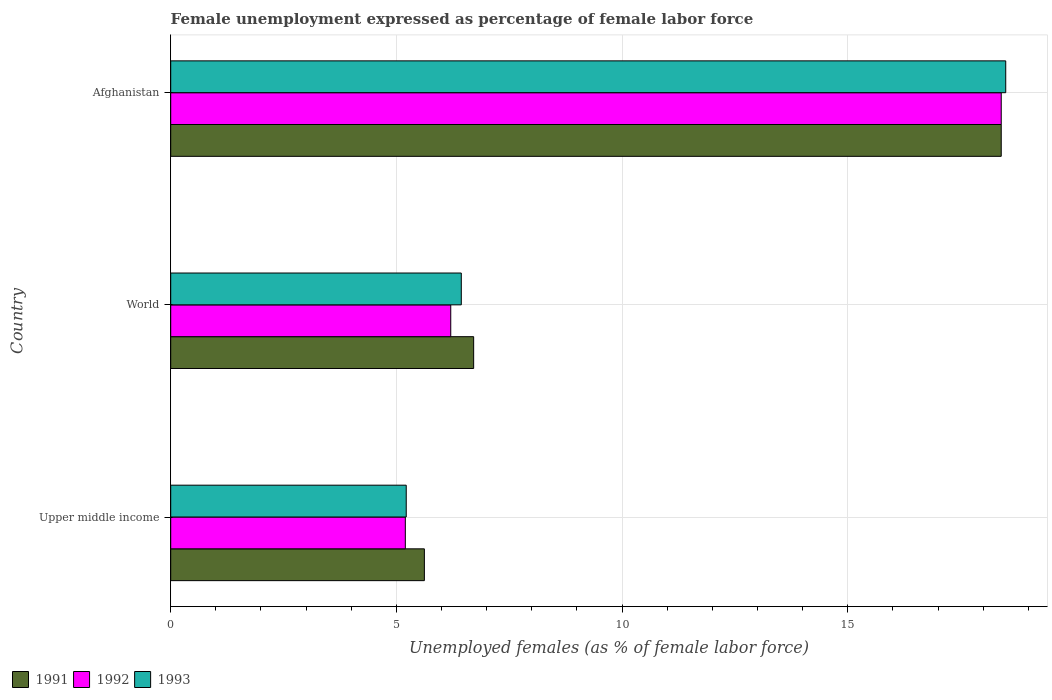How many different coloured bars are there?
Keep it short and to the point. 3. How many groups of bars are there?
Keep it short and to the point. 3. Are the number of bars on each tick of the Y-axis equal?
Provide a short and direct response. Yes. How many bars are there on the 3rd tick from the top?
Offer a terse response. 3. How many bars are there on the 2nd tick from the bottom?
Offer a terse response. 3. What is the label of the 1st group of bars from the top?
Offer a very short reply. Afghanistan. What is the unemployment in females in in 1991 in Afghanistan?
Give a very brief answer. 18.4. Across all countries, what is the maximum unemployment in females in in 1991?
Provide a succinct answer. 18.4. Across all countries, what is the minimum unemployment in females in in 1992?
Make the answer very short. 5.2. In which country was the unemployment in females in in 1993 maximum?
Make the answer very short. Afghanistan. In which country was the unemployment in females in in 1991 minimum?
Ensure brevity in your answer.  Upper middle income. What is the total unemployment in females in in 1991 in the graph?
Your response must be concise. 30.73. What is the difference between the unemployment in females in in 1991 in Upper middle income and that in World?
Provide a succinct answer. -1.09. What is the difference between the unemployment in females in in 1992 in Upper middle income and the unemployment in females in in 1991 in World?
Keep it short and to the point. -1.51. What is the average unemployment in females in in 1993 per country?
Ensure brevity in your answer.  10.05. What is the difference between the unemployment in females in in 1991 and unemployment in females in in 1992 in Upper middle income?
Your answer should be compact. 0.42. What is the ratio of the unemployment in females in in 1992 in Afghanistan to that in Upper middle income?
Give a very brief answer. 3.54. What is the difference between the highest and the second highest unemployment in females in in 1992?
Your response must be concise. 12.2. What is the difference between the highest and the lowest unemployment in females in in 1992?
Give a very brief answer. 13.2. In how many countries, is the unemployment in females in in 1993 greater than the average unemployment in females in in 1993 taken over all countries?
Keep it short and to the point. 1. Is it the case that in every country, the sum of the unemployment in females in in 1991 and unemployment in females in in 1992 is greater than the unemployment in females in in 1993?
Keep it short and to the point. Yes. Are all the bars in the graph horizontal?
Give a very brief answer. Yes. What is the difference between two consecutive major ticks on the X-axis?
Your response must be concise. 5. Where does the legend appear in the graph?
Provide a succinct answer. Bottom left. What is the title of the graph?
Provide a short and direct response. Female unemployment expressed as percentage of female labor force. What is the label or title of the X-axis?
Offer a very short reply. Unemployed females (as % of female labor force). What is the label or title of the Y-axis?
Offer a very short reply. Country. What is the Unemployed females (as % of female labor force) in 1991 in Upper middle income?
Ensure brevity in your answer.  5.62. What is the Unemployed females (as % of female labor force) of 1992 in Upper middle income?
Offer a terse response. 5.2. What is the Unemployed females (as % of female labor force) in 1993 in Upper middle income?
Offer a very short reply. 5.22. What is the Unemployed females (as % of female labor force) of 1991 in World?
Offer a terse response. 6.71. What is the Unemployed females (as % of female labor force) in 1992 in World?
Offer a very short reply. 6.2. What is the Unemployed females (as % of female labor force) in 1993 in World?
Make the answer very short. 6.44. What is the Unemployed females (as % of female labor force) of 1991 in Afghanistan?
Provide a short and direct response. 18.4. What is the Unemployed females (as % of female labor force) of 1992 in Afghanistan?
Offer a very short reply. 18.4. Across all countries, what is the maximum Unemployed females (as % of female labor force) of 1991?
Ensure brevity in your answer.  18.4. Across all countries, what is the maximum Unemployed females (as % of female labor force) of 1992?
Make the answer very short. 18.4. Across all countries, what is the maximum Unemployed females (as % of female labor force) in 1993?
Offer a terse response. 18.5. Across all countries, what is the minimum Unemployed females (as % of female labor force) of 1991?
Offer a very short reply. 5.62. Across all countries, what is the minimum Unemployed females (as % of female labor force) of 1992?
Your answer should be compact. 5.2. Across all countries, what is the minimum Unemployed females (as % of female labor force) in 1993?
Provide a short and direct response. 5.22. What is the total Unemployed females (as % of female labor force) of 1991 in the graph?
Offer a terse response. 30.73. What is the total Unemployed females (as % of female labor force) in 1992 in the graph?
Keep it short and to the point. 29.8. What is the total Unemployed females (as % of female labor force) in 1993 in the graph?
Offer a terse response. 30.16. What is the difference between the Unemployed females (as % of female labor force) of 1991 in Upper middle income and that in World?
Your answer should be compact. -1.09. What is the difference between the Unemployed females (as % of female labor force) in 1992 in Upper middle income and that in World?
Your answer should be compact. -1.01. What is the difference between the Unemployed females (as % of female labor force) in 1993 in Upper middle income and that in World?
Make the answer very short. -1.22. What is the difference between the Unemployed females (as % of female labor force) in 1991 in Upper middle income and that in Afghanistan?
Your answer should be compact. -12.78. What is the difference between the Unemployed females (as % of female labor force) in 1992 in Upper middle income and that in Afghanistan?
Offer a terse response. -13.2. What is the difference between the Unemployed females (as % of female labor force) in 1993 in Upper middle income and that in Afghanistan?
Keep it short and to the point. -13.28. What is the difference between the Unemployed females (as % of female labor force) of 1991 in World and that in Afghanistan?
Provide a short and direct response. -11.69. What is the difference between the Unemployed females (as % of female labor force) of 1992 in World and that in Afghanistan?
Provide a short and direct response. -12.2. What is the difference between the Unemployed females (as % of female labor force) of 1993 in World and that in Afghanistan?
Provide a short and direct response. -12.06. What is the difference between the Unemployed females (as % of female labor force) in 1991 in Upper middle income and the Unemployed females (as % of female labor force) in 1992 in World?
Your answer should be compact. -0.58. What is the difference between the Unemployed females (as % of female labor force) of 1991 in Upper middle income and the Unemployed females (as % of female labor force) of 1993 in World?
Offer a terse response. -0.82. What is the difference between the Unemployed females (as % of female labor force) in 1992 in Upper middle income and the Unemployed females (as % of female labor force) in 1993 in World?
Offer a very short reply. -1.24. What is the difference between the Unemployed females (as % of female labor force) in 1991 in Upper middle income and the Unemployed females (as % of female labor force) in 1992 in Afghanistan?
Make the answer very short. -12.78. What is the difference between the Unemployed females (as % of female labor force) of 1991 in Upper middle income and the Unemployed females (as % of female labor force) of 1993 in Afghanistan?
Give a very brief answer. -12.88. What is the difference between the Unemployed females (as % of female labor force) in 1992 in Upper middle income and the Unemployed females (as % of female labor force) in 1993 in Afghanistan?
Give a very brief answer. -13.3. What is the difference between the Unemployed females (as % of female labor force) in 1991 in World and the Unemployed females (as % of female labor force) in 1992 in Afghanistan?
Your response must be concise. -11.69. What is the difference between the Unemployed females (as % of female labor force) of 1991 in World and the Unemployed females (as % of female labor force) of 1993 in Afghanistan?
Offer a terse response. -11.79. What is the difference between the Unemployed females (as % of female labor force) in 1992 in World and the Unemployed females (as % of female labor force) in 1993 in Afghanistan?
Give a very brief answer. -12.3. What is the average Unemployed females (as % of female labor force) of 1991 per country?
Your answer should be very brief. 10.24. What is the average Unemployed females (as % of female labor force) in 1992 per country?
Ensure brevity in your answer.  9.93. What is the average Unemployed females (as % of female labor force) in 1993 per country?
Keep it short and to the point. 10.05. What is the difference between the Unemployed females (as % of female labor force) of 1991 and Unemployed females (as % of female labor force) of 1992 in Upper middle income?
Keep it short and to the point. 0.42. What is the difference between the Unemployed females (as % of female labor force) of 1991 and Unemployed females (as % of female labor force) of 1993 in Upper middle income?
Your answer should be very brief. 0.4. What is the difference between the Unemployed females (as % of female labor force) of 1992 and Unemployed females (as % of female labor force) of 1993 in Upper middle income?
Make the answer very short. -0.02. What is the difference between the Unemployed females (as % of female labor force) in 1991 and Unemployed females (as % of female labor force) in 1992 in World?
Your response must be concise. 0.51. What is the difference between the Unemployed females (as % of female labor force) in 1991 and Unemployed females (as % of female labor force) in 1993 in World?
Keep it short and to the point. 0.27. What is the difference between the Unemployed females (as % of female labor force) of 1992 and Unemployed females (as % of female labor force) of 1993 in World?
Make the answer very short. -0.23. What is the ratio of the Unemployed females (as % of female labor force) of 1991 in Upper middle income to that in World?
Give a very brief answer. 0.84. What is the ratio of the Unemployed females (as % of female labor force) of 1992 in Upper middle income to that in World?
Keep it short and to the point. 0.84. What is the ratio of the Unemployed females (as % of female labor force) in 1993 in Upper middle income to that in World?
Keep it short and to the point. 0.81. What is the ratio of the Unemployed females (as % of female labor force) in 1991 in Upper middle income to that in Afghanistan?
Give a very brief answer. 0.31. What is the ratio of the Unemployed females (as % of female labor force) of 1992 in Upper middle income to that in Afghanistan?
Provide a short and direct response. 0.28. What is the ratio of the Unemployed females (as % of female labor force) of 1993 in Upper middle income to that in Afghanistan?
Keep it short and to the point. 0.28. What is the ratio of the Unemployed females (as % of female labor force) of 1991 in World to that in Afghanistan?
Your response must be concise. 0.36. What is the ratio of the Unemployed females (as % of female labor force) of 1992 in World to that in Afghanistan?
Your answer should be compact. 0.34. What is the ratio of the Unemployed females (as % of female labor force) in 1993 in World to that in Afghanistan?
Your answer should be very brief. 0.35. What is the difference between the highest and the second highest Unemployed females (as % of female labor force) in 1991?
Ensure brevity in your answer.  11.69. What is the difference between the highest and the second highest Unemployed females (as % of female labor force) of 1992?
Your answer should be compact. 12.2. What is the difference between the highest and the second highest Unemployed females (as % of female labor force) in 1993?
Keep it short and to the point. 12.06. What is the difference between the highest and the lowest Unemployed females (as % of female labor force) of 1991?
Offer a very short reply. 12.78. What is the difference between the highest and the lowest Unemployed females (as % of female labor force) in 1992?
Give a very brief answer. 13.2. What is the difference between the highest and the lowest Unemployed females (as % of female labor force) in 1993?
Give a very brief answer. 13.28. 